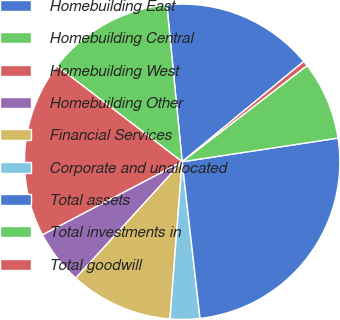Convert chart to OTSL. <chart><loc_0><loc_0><loc_500><loc_500><pie_chart><fcel>Homebuilding East<fcel>Homebuilding Central<fcel>Homebuilding West<fcel>Homebuilding Other<fcel>Financial Services<fcel>Corporate and unallocated<fcel>Total assets<fcel>Total investments in<fcel>Total goodwill<nl><fcel>15.57%<fcel>13.06%<fcel>18.07%<fcel>5.54%<fcel>10.55%<fcel>3.04%<fcel>25.59%<fcel>8.05%<fcel>0.53%<nl></chart> 